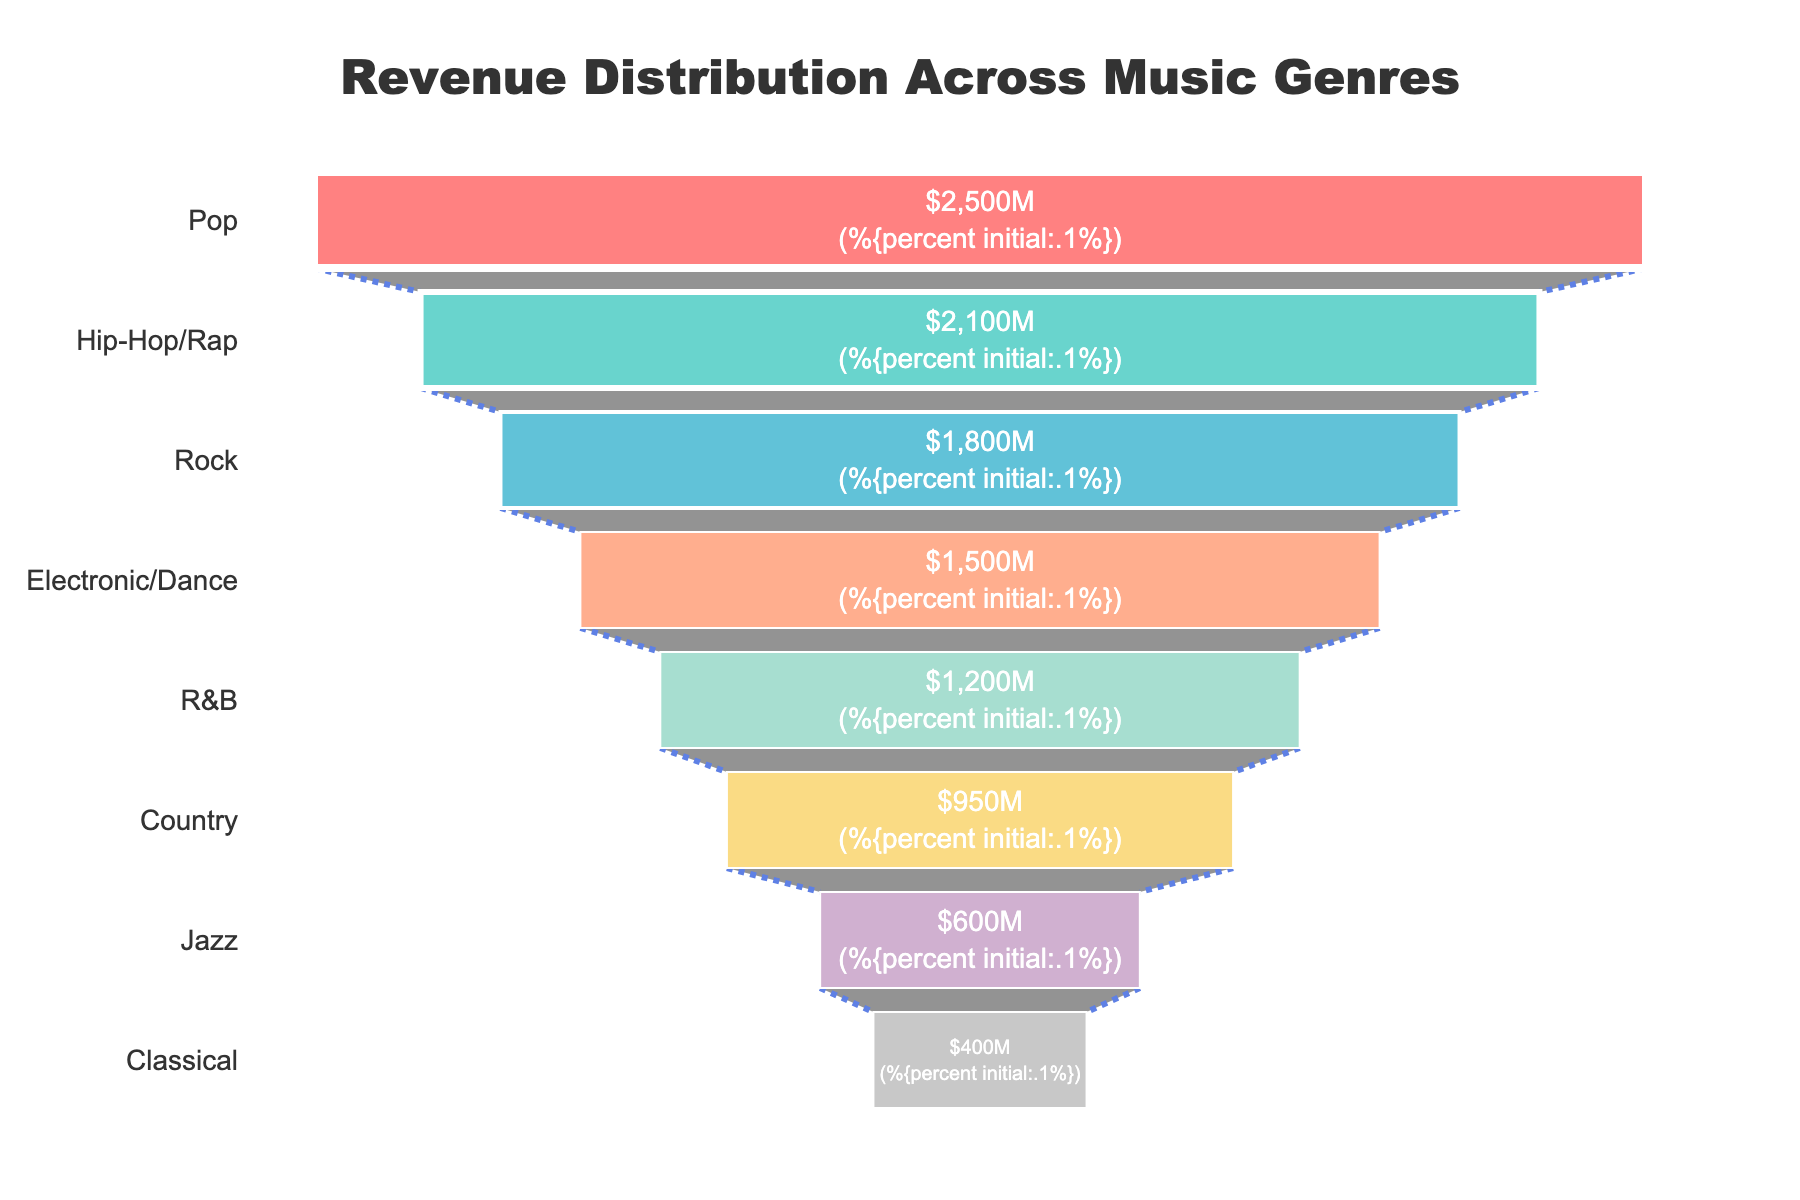What genre generates the highest revenue? The highest revenue is shown at the top of the Funnel Chart. Identify the genre at the top.
Answer: Pop How much revenue does the Jazz genre generate? Look for the Jazz label on the Funnel Chart and note the value associated with it.
Answer: 600 million USD Which two genres combined generate more revenue than the Electronic/Dance genre? Sum the revenues of different genre pairs and compare to the Electronic/Dance revenue. Jazz (600) + Classical (400) = 1000, R&B (1200) + Country (950) = 2150 exceeds 1500. Therefore, R&B and Country combined generate more.
Answer: R&B and Country How does the revenue from Hip-Hop/Rap compare to Rock? Find the revenue figures for Hip-Hop/Rap and Rock and compare them. Hip-Hop/Rap (2100) > Rock (1800).
Answer: Hip-Hop/Rap generates more revenue What percentage of total revenue is contributed by the Country genre? Calculate the percentage by dividing the Country revenue by the sum of all genres' revenues and multiplying by 100. Total revenue = 2500 + 2100 + 1800 + 1500 + 1200 + 950 + 600 + 400 = 12050. (950 / 12050) * 100 = 7.88%.
Answer: 7.88% How much more revenue does Pop generate compared to Electronic/Dance? Subtract the revenue of Electronic/Dance from the revenue of Pop (2500 - 1500 = 1000).
Answer: 1000 million USD What is the combined revenue of the top three genres? Sum the revenues of Pop, Hip-Hop/Rap, and Rock. (2500 + 2100 + 1800) = 6400.
Answer: 6400 million USD What is the smallest revenue category in the chart? Identify the genre with the smallest value at the bottom of the Funnel Chart.
Answer: Classical Which genre is directly below the Rock genre in terms of revenue? Observe which genre is listed directly below Rock on the Funnel Chart.
Answer: Electronic/Dance What is the total revenue generated by genres that produce less than 1000 million USD each? Sum the revenues of genres with less than 1000 million USD (600 + 400).
Answer: 1000 million USD 